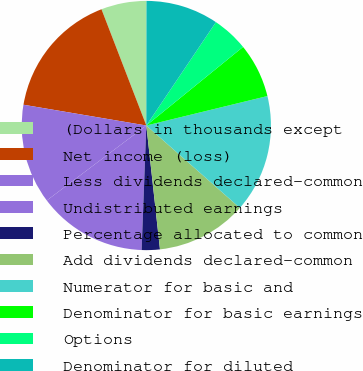Convert chart to OTSL. <chart><loc_0><loc_0><loc_500><loc_500><pie_chart><fcel>(Dollars in thousands except<fcel>Net income (loss)<fcel>Less dividends declared-common<fcel>Undistributed earnings<fcel>Percentage allocated to common<fcel>Add dividends declared-common<fcel>Numerator for basic and<fcel>Denominator for basic earnings<fcel>Options<fcel>Denominator for diluted<nl><fcel>5.88%<fcel>16.47%<fcel>12.94%<fcel>14.12%<fcel>2.35%<fcel>11.76%<fcel>15.29%<fcel>7.06%<fcel>4.71%<fcel>9.41%<nl></chart> 